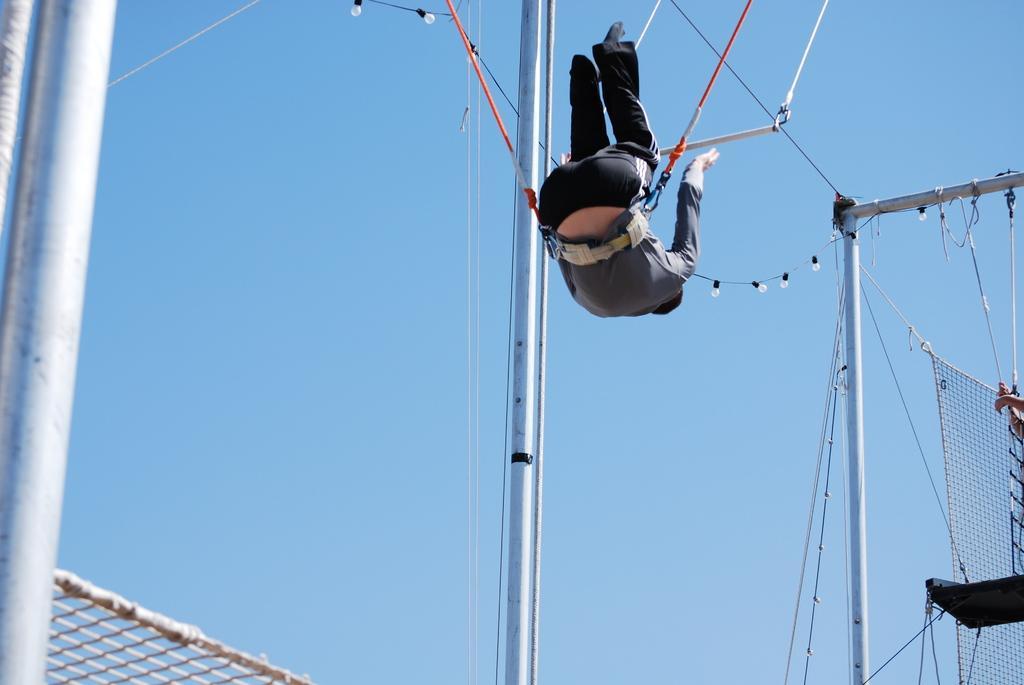Describe this image in one or two sentences. In the picture we can see a man hanging to the ropes to his hip upside down and beside him we can see a pole and in front of him we can see a pole with some bulbs to it and a net tied to it and in the background we can see the sky. 